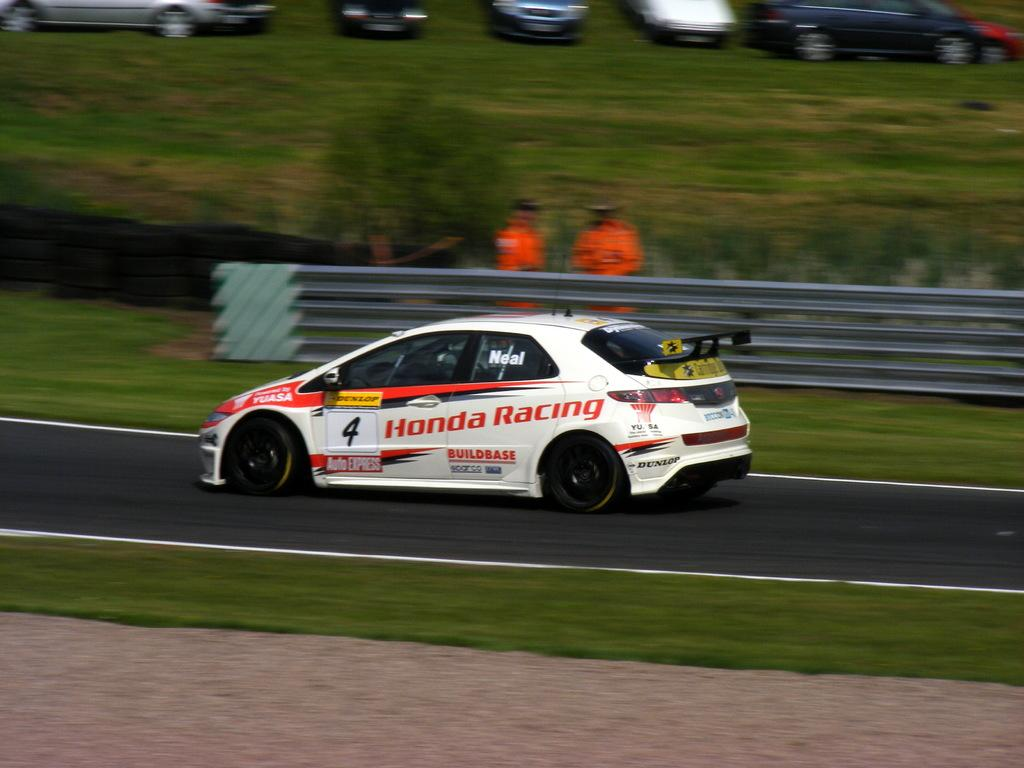<image>
Present a compact description of the photo's key features. A race car that has Honda Racing painted on the side. 